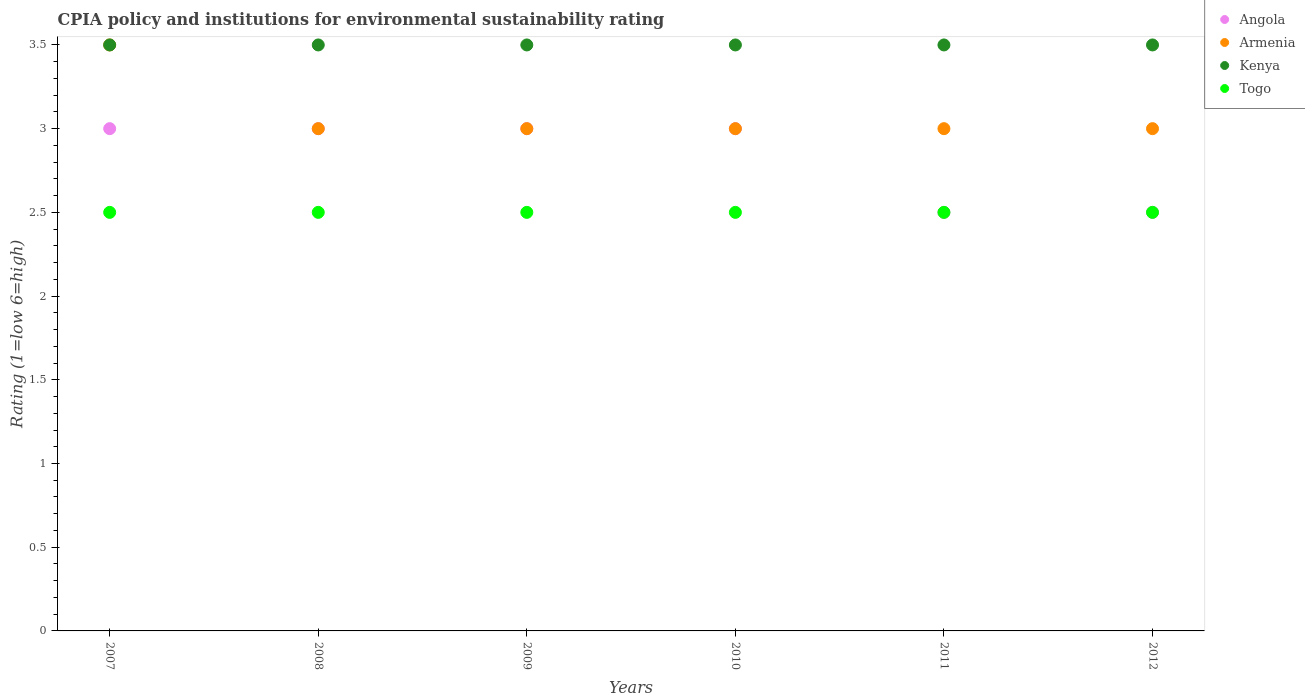How many different coloured dotlines are there?
Make the answer very short. 4. What is the CPIA rating in Kenya in 2012?
Make the answer very short. 3.5. Across all years, what is the maximum CPIA rating in Angola?
Make the answer very short. 3. Across all years, what is the minimum CPIA rating in Togo?
Give a very brief answer. 2.5. What is the average CPIA rating in Armenia per year?
Provide a short and direct response. 3.08. In the year 2010, what is the difference between the CPIA rating in Angola and CPIA rating in Armenia?
Ensure brevity in your answer.  0. In how many years, is the CPIA rating in Armenia greater than 1.9?
Provide a succinct answer. 6. Is the CPIA rating in Kenya in 2008 less than that in 2010?
Provide a succinct answer. No. What is the difference between the highest and the second highest CPIA rating in Togo?
Your answer should be very brief. 0. Is the CPIA rating in Armenia strictly greater than the CPIA rating in Angola over the years?
Keep it short and to the point. No. Is the CPIA rating in Angola strictly less than the CPIA rating in Togo over the years?
Offer a very short reply. No. What is the difference between two consecutive major ticks on the Y-axis?
Keep it short and to the point. 0.5. Are the values on the major ticks of Y-axis written in scientific E-notation?
Your answer should be compact. No. Does the graph contain grids?
Your answer should be compact. No. Where does the legend appear in the graph?
Offer a terse response. Top right. How many legend labels are there?
Provide a succinct answer. 4. How are the legend labels stacked?
Offer a very short reply. Vertical. What is the title of the graph?
Your response must be concise. CPIA policy and institutions for environmental sustainability rating. What is the Rating (1=low 6=high) in Kenya in 2007?
Give a very brief answer. 3.5. What is the Rating (1=low 6=high) of Togo in 2008?
Give a very brief answer. 2.5. What is the Rating (1=low 6=high) in Kenya in 2009?
Your response must be concise. 3.5. What is the Rating (1=low 6=high) in Kenya in 2010?
Your answer should be compact. 3.5. What is the Rating (1=low 6=high) of Armenia in 2011?
Keep it short and to the point. 3. What is the Rating (1=low 6=high) of Angola in 2012?
Ensure brevity in your answer.  2.5. What is the Rating (1=low 6=high) of Togo in 2012?
Make the answer very short. 2.5. Across all years, what is the maximum Rating (1=low 6=high) in Togo?
Offer a very short reply. 2.5. Across all years, what is the minimum Rating (1=low 6=high) of Angola?
Give a very brief answer. 2.5. Across all years, what is the minimum Rating (1=low 6=high) of Kenya?
Offer a very short reply. 3.5. Across all years, what is the minimum Rating (1=low 6=high) of Togo?
Make the answer very short. 2.5. What is the total Rating (1=low 6=high) of Angola in the graph?
Offer a very short reply. 17. What is the total Rating (1=low 6=high) in Kenya in the graph?
Your response must be concise. 21. What is the difference between the Rating (1=low 6=high) of Angola in 2007 and that in 2008?
Your answer should be compact. 0. What is the difference between the Rating (1=low 6=high) of Armenia in 2007 and that in 2008?
Provide a short and direct response. 0.5. What is the difference between the Rating (1=low 6=high) in Kenya in 2007 and that in 2008?
Make the answer very short. 0. What is the difference between the Rating (1=low 6=high) in Togo in 2007 and that in 2009?
Give a very brief answer. 0. What is the difference between the Rating (1=low 6=high) in Armenia in 2007 and that in 2010?
Give a very brief answer. 0.5. What is the difference between the Rating (1=low 6=high) of Kenya in 2007 and that in 2010?
Ensure brevity in your answer.  0. What is the difference between the Rating (1=low 6=high) of Kenya in 2008 and that in 2009?
Give a very brief answer. 0. What is the difference between the Rating (1=low 6=high) of Angola in 2008 and that in 2010?
Provide a short and direct response. 0. What is the difference between the Rating (1=low 6=high) of Armenia in 2008 and that in 2010?
Provide a short and direct response. 0. What is the difference between the Rating (1=low 6=high) of Kenya in 2008 and that in 2010?
Your response must be concise. 0. What is the difference between the Rating (1=low 6=high) of Angola in 2008 and that in 2011?
Give a very brief answer. 0.5. What is the difference between the Rating (1=low 6=high) of Kenya in 2008 and that in 2011?
Keep it short and to the point. 0. What is the difference between the Rating (1=low 6=high) in Angola in 2009 and that in 2010?
Ensure brevity in your answer.  0. What is the difference between the Rating (1=low 6=high) of Togo in 2009 and that in 2010?
Provide a succinct answer. 0. What is the difference between the Rating (1=low 6=high) of Angola in 2009 and that in 2011?
Offer a terse response. 0.5. What is the difference between the Rating (1=low 6=high) of Armenia in 2009 and that in 2011?
Your response must be concise. 0. What is the difference between the Rating (1=low 6=high) in Togo in 2009 and that in 2011?
Your response must be concise. 0. What is the difference between the Rating (1=low 6=high) of Angola in 2009 and that in 2012?
Your answer should be compact. 0.5. What is the difference between the Rating (1=low 6=high) in Armenia in 2009 and that in 2012?
Your answer should be very brief. 0. What is the difference between the Rating (1=low 6=high) of Togo in 2009 and that in 2012?
Ensure brevity in your answer.  0. What is the difference between the Rating (1=low 6=high) in Armenia in 2010 and that in 2011?
Ensure brevity in your answer.  0. What is the difference between the Rating (1=low 6=high) of Kenya in 2010 and that in 2011?
Your answer should be compact. 0. What is the difference between the Rating (1=low 6=high) of Angola in 2010 and that in 2012?
Ensure brevity in your answer.  0.5. What is the difference between the Rating (1=low 6=high) of Armenia in 2010 and that in 2012?
Offer a terse response. 0. What is the difference between the Rating (1=low 6=high) in Togo in 2010 and that in 2012?
Provide a short and direct response. 0. What is the difference between the Rating (1=low 6=high) of Angola in 2011 and that in 2012?
Offer a very short reply. 0. What is the difference between the Rating (1=low 6=high) in Armenia in 2011 and that in 2012?
Provide a short and direct response. 0. What is the difference between the Rating (1=low 6=high) of Togo in 2011 and that in 2012?
Give a very brief answer. 0. What is the difference between the Rating (1=low 6=high) in Angola in 2007 and the Rating (1=low 6=high) in Armenia in 2008?
Offer a terse response. 0. What is the difference between the Rating (1=low 6=high) of Angola in 2007 and the Rating (1=low 6=high) of Togo in 2008?
Your answer should be very brief. 0.5. What is the difference between the Rating (1=low 6=high) in Armenia in 2007 and the Rating (1=low 6=high) in Togo in 2008?
Give a very brief answer. 1. What is the difference between the Rating (1=low 6=high) in Angola in 2007 and the Rating (1=low 6=high) in Armenia in 2009?
Give a very brief answer. 0. What is the difference between the Rating (1=low 6=high) in Armenia in 2007 and the Rating (1=low 6=high) in Kenya in 2009?
Make the answer very short. 0. What is the difference between the Rating (1=low 6=high) in Kenya in 2007 and the Rating (1=low 6=high) in Togo in 2009?
Provide a short and direct response. 1. What is the difference between the Rating (1=low 6=high) in Angola in 2007 and the Rating (1=low 6=high) in Armenia in 2010?
Offer a very short reply. 0. What is the difference between the Rating (1=low 6=high) of Angola in 2007 and the Rating (1=low 6=high) of Kenya in 2010?
Give a very brief answer. -0.5. What is the difference between the Rating (1=low 6=high) of Armenia in 2007 and the Rating (1=low 6=high) of Togo in 2010?
Ensure brevity in your answer.  1. What is the difference between the Rating (1=low 6=high) of Kenya in 2007 and the Rating (1=low 6=high) of Togo in 2010?
Provide a short and direct response. 1. What is the difference between the Rating (1=low 6=high) of Angola in 2007 and the Rating (1=low 6=high) of Armenia in 2011?
Ensure brevity in your answer.  0. What is the difference between the Rating (1=low 6=high) of Armenia in 2007 and the Rating (1=low 6=high) of Kenya in 2011?
Give a very brief answer. 0. What is the difference between the Rating (1=low 6=high) in Angola in 2007 and the Rating (1=low 6=high) in Armenia in 2012?
Offer a terse response. 0. What is the difference between the Rating (1=low 6=high) of Angola in 2007 and the Rating (1=low 6=high) of Kenya in 2012?
Keep it short and to the point. -0.5. What is the difference between the Rating (1=low 6=high) in Angola in 2008 and the Rating (1=low 6=high) in Togo in 2009?
Provide a succinct answer. 0.5. What is the difference between the Rating (1=low 6=high) in Armenia in 2008 and the Rating (1=low 6=high) in Kenya in 2009?
Your answer should be compact. -0.5. What is the difference between the Rating (1=low 6=high) of Armenia in 2008 and the Rating (1=low 6=high) of Togo in 2009?
Your response must be concise. 0.5. What is the difference between the Rating (1=low 6=high) of Kenya in 2008 and the Rating (1=low 6=high) of Togo in 2009?
Give a very brief answer. 1. What is the difference between the Rating (1=low 6=high) in Angola in 2008 and the Rating (1=low 6=high) in Armenia in 2010?
Offer a terse response. 0. What is the difference between the Rating (1=low 6=high) in Angola in 2008 and the Rating (1=low 6=high) in Kenya in 2010?
Offer a terse response. -0.5. What is the difference between the Rating (1=low 6=high) in Armenia in 2008 and the Rating (1=low 6=high) in Kenya in 2010?
Your response must be concise. -0.5. What is the difference between the Rating (1=low 6=high) in Armenia in 2008 and the Rating (1=low 6=high) in Togo in 2010?
Ensure brevity in your answer.  0.5. What is the difference between the Rating (1=low 6=high) in Angola in 2008 and the Rating (1=low 6=high) in Armenia in 2011?
Ensure brevity in your answer.  0. What is the difference between the Rating (1=low 6=high) in Angola in 2008 and the Rating (1=low 6=high) in Kenya in 2011?
Ensure brevity in your answer.  -0.5. What is the difference between the Rating (1=low 6=high) in Armenia in 2008 and the Rating (1=low 6=high) in Kenya in 2011?
Offer a very short reply. -0.5. What is the difference between the Rating (1=low 6=high) of Armenia in 2008 and the Rating (1=low 6=high) of Togo in 2011?
Make the answer very short. 0.5. What is the difference between the Rating (1=low 6=high) of Angola in 2008 and the Rating (1=low 6=high) of Kenya in 2012?
Your answer should be very brief. -0.5. What is the difference between the Rating (1=low 6=high) in Armenia in 2008 and the Rating (1=low 6=high) in Togo in 2012?
Your answer should be compact. 0.5. What is the difference between the Rating (1=low 6=high) of Kenya in 2008 and the Rating (1=low 6=high) of Togo in 2012?
Offer a terse response. 1. What is the difference between the Rating (1=low 6=high) of Angola in 2009 and the Rating (1=low 6=high) of Armenia in 2010?
Your answer should be compact. 0. What is the difference between the Rating (1=low 6=high) in Kenya in 2009 and the Rating (1=low 6=high) in Togo in 2010?
Your answer should be compact. 1. What is the difference between the Rating (1=low 6=high) of Angola in 2009 and the Rating (1=low 6=high) of Armenia in 2011?
Ensure brevity in your answer.  0. What is the difference between the Rating (1=low 6=high) in Angola in 2009 and the Rating (1=low 6=high) in Kenya in 2011?
Keep it short and to the point. -0.5. What is the difference between the Rating (1=low 6=high) of Armenia in 2009 and the Rating (1=low 6=high) of Kenya in 2011?
Make the answer very short. -0.5. What is the difference between the Rating (1=low 6=high) in Kenya in 2009 and the Rating (1=low 6=high) in Togo in 2011?
Offer a very short reply. 1. What is the difference between the Rating (1=low 6=high) in Angola in 2009 and the Rating (1=low 6=high) in Armenia in 2012?
Your response must be concise. 0. What is the difference between the Rating (1=low 6=high) of Angola in 2009 and the Rating (1=low 6=high) of Kenya in 2012?
Offer a terse response. -0.5. What is the difference between the Rating (1=low 6=high) of Angola in 2009 and the Rating (1=low 6=high) of Togo in 2012?
Offer a very short reply. 0.5. What is the difference between the Rating (1=low 6=high) of Armenia in 2009 and the Rating (1=low 6=high) of Kenya in 2012?
Give a very brief answer. -0.5. What is the difference between the Rating (1=low 6=high) of Angola in 2010 and the Rating (1=low 6=high) of Armenia in 2011?
Give a very brief answer. 0. What is the difference between the Rating (1=low 6=high) of Angola in 2010 and the Rating (1=low 6=high) of Togo in 2011?
Make the answer very short. 0.5. What is the difference between the Rating (1=low 6=high) in Angola in 2010 and the Rating (1=low 6=high) in Armenia in 2012?
Give a very brief answer. 0. What is the difference between the Rating (1=low 6=high) in Angola in 2010 and the Rating (1=low 6=high) in Kenya in 2012?
Give a very brief answer. -0.5. What is the difference between the Rating (1=low 6=high) of Angola in 2010 and the Rating (1=low 6=high) of Togo in 2012?
Keep it short and to the point. 0.5. What is the difference between the Rating (1=low 6=high) in Kenya in 2010 and the Rating (1=low 6=high) in Togo in 2012?
Give a very brief answer. 1. What is the difference between the Rating (1=low 6=high) of Angola in 2011 and the Rating (1=low 6=high) of Armenia in 2012?
Offer a terse response. -0.5. What is the difference between the Rating (1=low 6=high) of Angola in 2011 and the Rating (1=low 6=high) of Kenya in 2012?
Provide a succinct answer. -1. What is the average Rating (1=low 6=high) in Angola per year?
Give a very brief answer. 2.83. What is the average Rating (1=low 6=high) in Armenia per year?
Give a very brief answer. 3.08. What is the average Rating (1=low 6=high) of Kenya per year?
Your answer should be compact. 3.5. What is the average Rating (1=low 6=high) in Togo per year?
Keep it short and to the point. 2.5. In the year 2007, what is the difference between the Rating (1=low 6=high) in Angola and Rating (1=low 6=high) in Kenya?
Provide a succinct answer. -0.5. In the year 2007, what is the difference between the Rating (1=low 6=high) of Kenya and Rating (1=low 6=high) of Togo?
Ensure brevity in your answer.  1. In the year 2008, what is the difference between the Rating (1=low 6=high) in Angola and Rating (1=low 6=high) in Armenia?
Your answer should be very brief. 0. In the year 2008, what is the difference between the Rating (1=low 6=high) in Angola and Rating (1=low 6=high) in Togo?
Ensure brevity in your answer.  0.5. In the year 2008, what is the difference between the Rating (1=low 6=high) in Armenia and Rating (1=low 6=high) in Kenya?
Provide a succinct answer. -0.5. In the year 2009, what is the difference between the Rating (1=low 6=high) in Angola and Rating (1=low 6=high) in Kenya?
Give a very brief answer. -0.5. In the year 2009, what is the difference between the Rating (1=low 6=high) in Angola and Rating (1=low 6=high) in Togo?
Keep it short and to the point. 0.5. In the year 2010, what is the difference between the Rating (1=low 6=high) in Angola and Rating (1=low 6=high) in Armenia?
Offer a very short reply. 0. In the year 2010, what is the difference between the Rating (1=low 6=high) of Armenia and Rating (1=low 6=high) of Kenya?
Provide a succinct answer. -0.5. In the year 2010, what is the difference between the Rating (1=low 6=high) of Kenya and Rating (1=low 6=high) of Togo?
Make the answer very short. 1. In the year 2011, what is the difference between the Rating (1=low 6=high) of Angola and Rating (1=low 6=high) of Kenya?
Give a very brief answer. -1. In the year 2011, what is the difference between the Rating (1=low 6=high) in Angola and Rating (1=low 6=high) in Togo?
Your answer should be compact. 0. In the year 2011, what is the difference between the Rating (1=low 6=high) of Armenia and Rating (1=low 6=high) of Togo?
Offer a very short reply. 0.5. In the year 2011, what is the difference between the Rating (1=low 6=high) of Kenya and Rating (1=low 6=high) of Togo?
Provide a succinct answer. 1. In the year 2012, what is the difference between the Rating (1=low 6=high) in Angola and Rating (1=low 6=high) in Kenya?
Offer a very short reply. -1. In the year 2012, what is the difference between the Rating (1=low 6=high) in Armenia and Rating (1=low 6=high) in Kenya?
Ensure brevity in your answer.  -0.5. In the year 2012, what is the difference between the Rating (1=low 6=high) of Kenya and Rating (1=low 6=high) of Togo?
Keep it short and to the point. 1. What is the ratio of the Rating (1=low 6=high) in Angola in 2007 to that in 2008?
Provide a succinct answer. 1. What is the ratio of the Rating (1=low 6=high) of Armenia in 2007 to that in 2008?
Provide a succinct answer. 1.17. What is the ratio of the Rating (1=low 6=high) of Angola in 2007 to that in 2009?
Offer a terse response. 1. What is the ratio of the Rating (1=low 6=high) in Togo in 2007 to that in 2009?
Provide a short and direct response. 1. What is the ratio of the Rating (1=low 6=high) of Kenya in 2007 to that in 2010?
Ensure brevity in your answer.  1. What is the ratio of the Rating (1=low 6=high) of Togo in 2007 to that in 2010?
Your response must be concise. 1. What is the ratio of the Rating (1=low 6=high) of Armenia in 2007 to that in 2011?
Ensure brevity in your answer.  1.17. What is the ratio of the Rating (1=low 6=high) of Kenya in 2007 to that in 2011?
Give a very brief answer. 1. What is the ratio of the Rating (1=low 6=high) of Togo in 2007 to that in 2011?
Offer a terse response. 1. What is the ratio of the Rating (1=low 6=high) in Togo in 2007 to that in 2012?
Ensure brevity in your answer.  1. What is the ratio of the Rating (1=low 6=high) in Angola in 2008 to that in 2009?
Provide a short and direct response. 1. What is the ratio of the Rating (1=low 6=high) of Angola in 2008 to that in 2010?
Provide a succinct answer. 1. What is the ratio of the Rating (1=low 6=high) of Armenia in 2008 to that in 2010?
Your answer should be very brief. 1. What is the ratio of the Rating (1=low 6=high) of Kenya in 2008 to that in 2010?
Your answer should be very brief. 1. What is the ratio of the Rating (1=low 6=high) of Angola in 2008 to that in 2011?
Make the answer very short. 1.2. What is the ratio of the Rating (1=low 6=high) in Togo in 2008 to that in 2011?
Ensure brevity in your answer.  1. What is the ratio of the Rating (1=low 6=high) of Angola in 2009 to that in 2011?
Offer a terse response. 1.2. What is the ratio of the Rating (1=low 6=high) in Armenia in 2009 to that in 2011?
Offer a terse response. 1. What is the ratio of the Rating (1=low 6=high) of Kenya in 2009 to that in 2011?
Provide a short and direct response. 1. What is the ratio of the Rating (1=low 6=high) in Togo in 2009 to that in 2011?
Provide a succinct answer. 1. What is the ratio of the Rating (1=low 6=high) in Armenia in 2009 to that in 2012?
Provide a short and direct response. 1. What is the ratio of the Rating (1=low 6=high) of Angola in 2010 to that in 2011?
Offer a terse response. 1.2. What is the ratio of the Rating (1=low 6=high) in Togo in 2010 to that in 2011?
Provide a succinct answer. 1. What is the ratio of the Rating (1=low 6=high) in Armenia in 2010 to that in 2012?
Provide a short and direct response. 1. What is the ratio of the Rating (1=low 6=high) in Angola in 2011 to that in 2012?
Offer a terse response. 1. What is the ratio of the Rating (1=low 6=high) of Kenya in 2011 to that in 2012?
Your answer should be very brief. 1. What is the difference between the highest and the second highest Rating (1=low 6=high) of Armenia?
Your answer should be compact. 0.5. What is the difference between the highest and the lowest Rating (1=low 6=high) of Angola?
Make the answer very short. 0.5. 